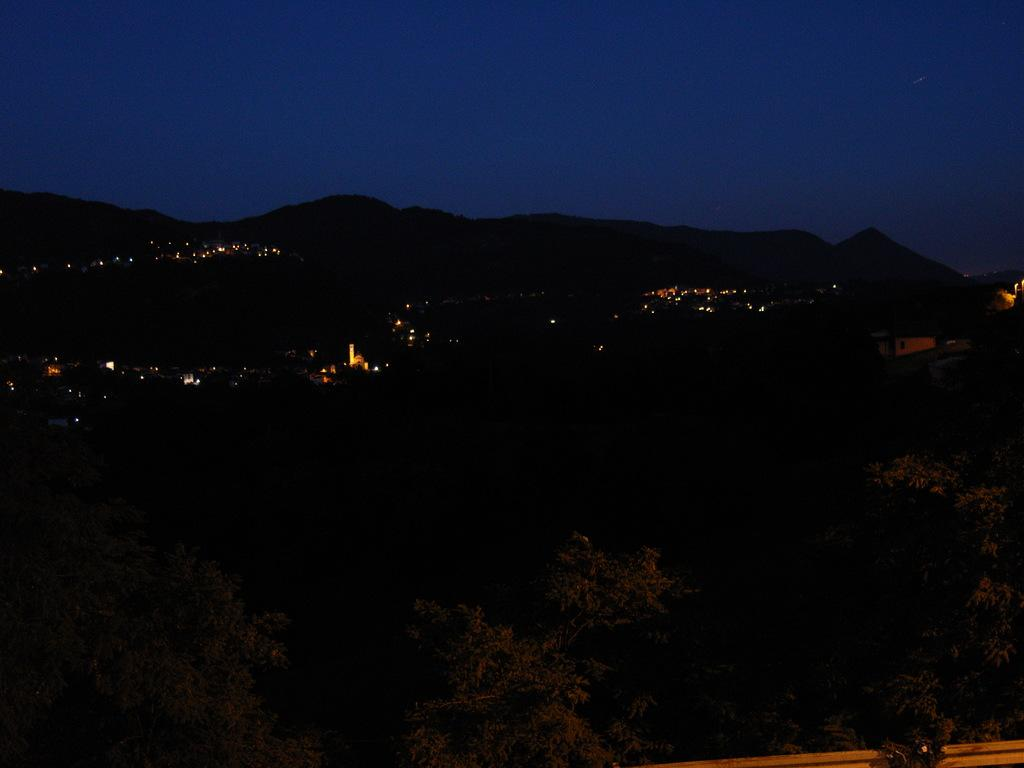What is the overall lighting condition of the image? The image is dark. What type of natural elements can be seen at the bottom of the image? There are trees at the bottom of the image. What can be seen in the distance in the image? Lights, buildings, objects, mountains, and the sky are visible in the background of the image. What type of tank is visible in the image? There is no tank present in the image. What unit of measurement is used to determine the height of the mountains in the image? The image does not provide any information about the height of the mountains or any unit of measurement. 